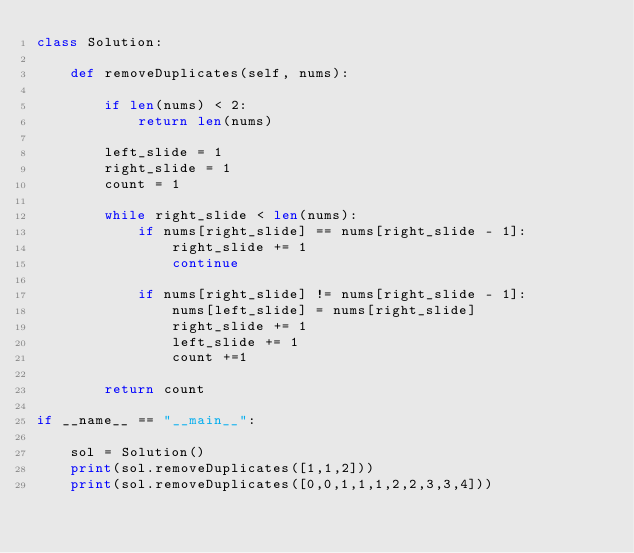<code> <loc_0><loc_0><loc_500><loc_500><_Python_>class Solution:
    
    def removeDuplicates(self, nums):
        
        if len(nums) < 2:
            return len(nums)
        
        left_slide = 1
        right_slide = 1
        count = 1
        
        while right_slide < len(nums):
            if nums[right_slide] == nums[right_slide - 1]:
                right_slide += 1
                continue
                
            if nums[right_slide] != nums[right_slide - 1]:
                nums[left_slide] = nums[right_slide]
                right_slide += 1
                left_slide += 1
                count +=1
                
        return count

if __name__ == "__main__":
    
    sol = Solution()
    print(sol.removeDuplicates([1,1,2]))
    print(sol.removeDuplicates([0,0,1,1,1,2,2,3,3,4]))
    </code> 